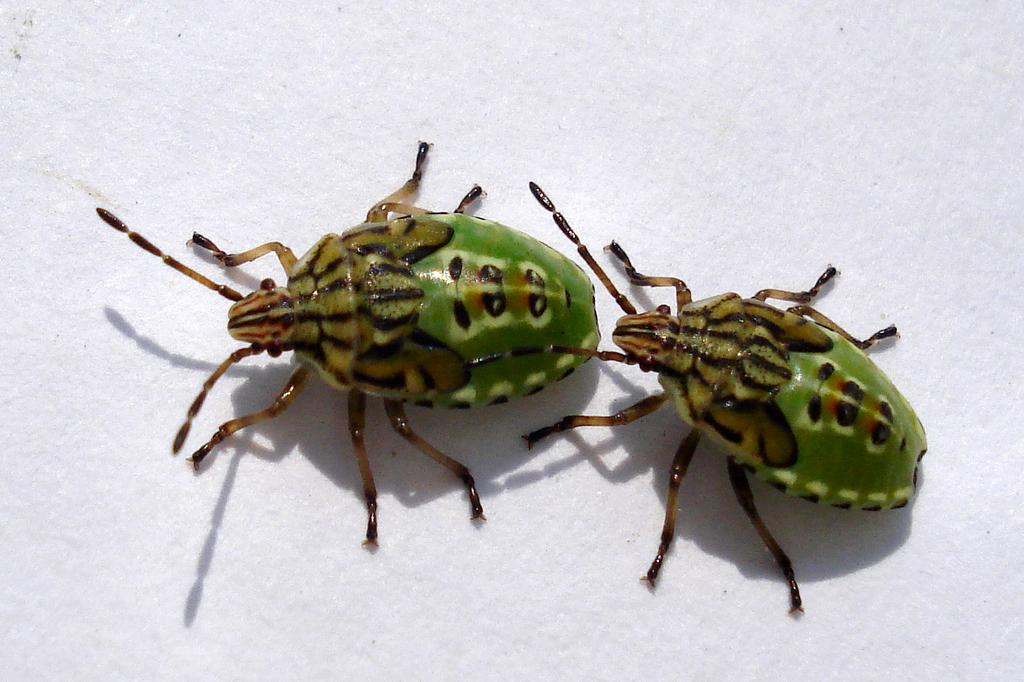What type of creatures are present in the image? There are two bugs in the image. What is the color of the surface on which the bugs are located? The bugs are on a white surface. What type of prose can be seen in the image? There is no prose present in the image; it features two bugs on a white surface. What type of yarn is being used by the bugs in the image? There is no yarn present in the image, nor are the bugs using any yarn. 